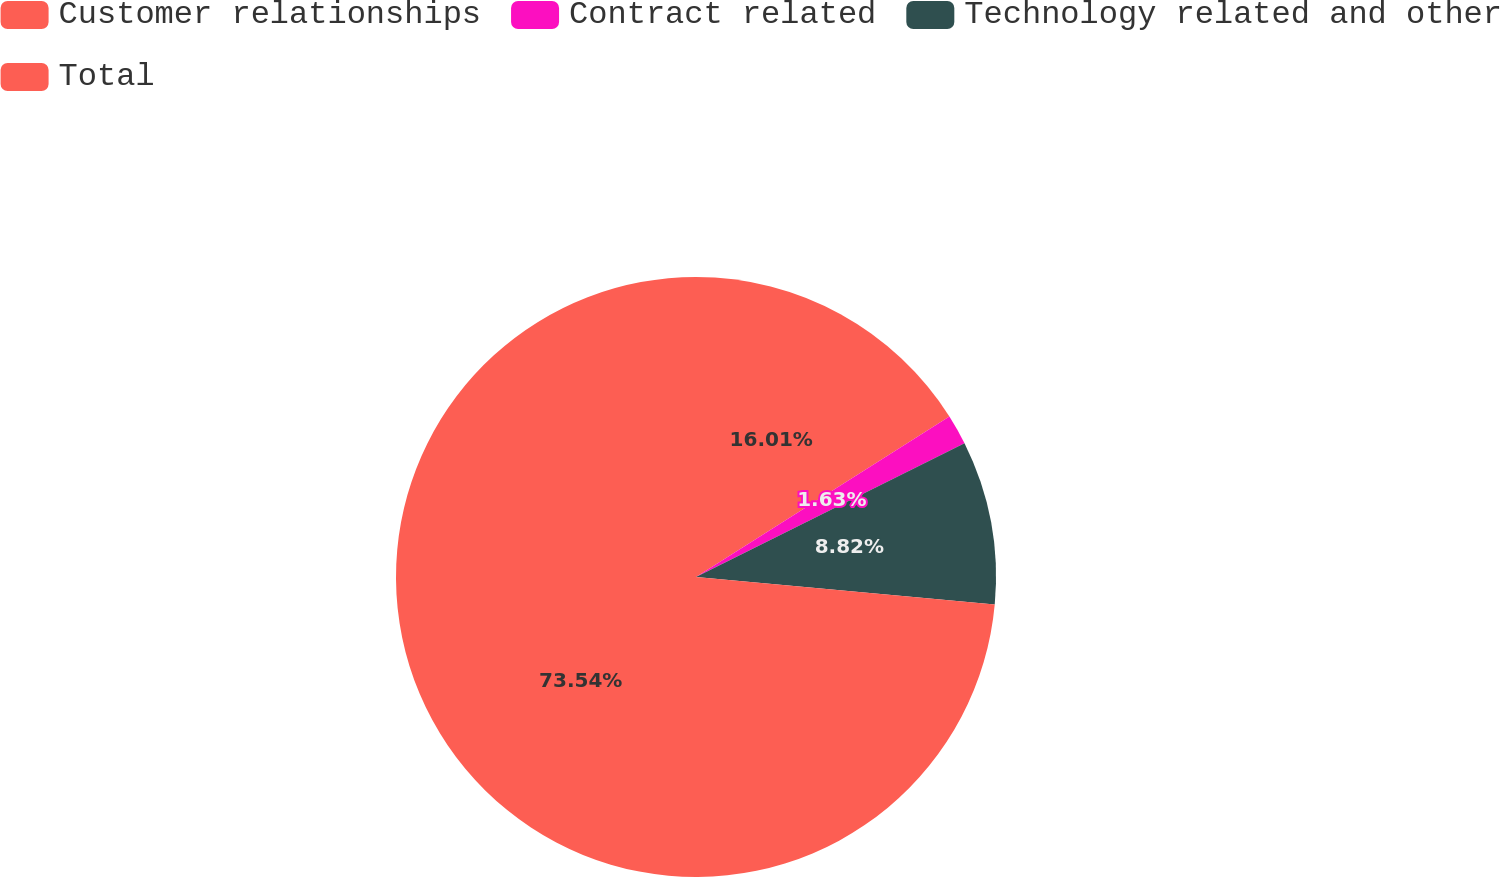<chart> <loc_0><loc_0><loc_500><loc_500><pie_chart><fcel>Customer relationships<fcel>Contract related<fcel>Technology related and other<fcel>Total<nl><fcel>16.01%<fcel>1.63%<fcel>8.82%<fcel>73.54%<nl></chart> 